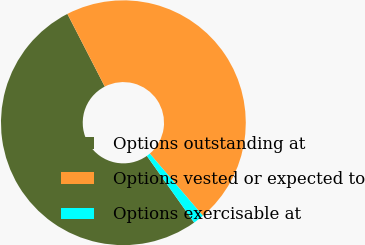<chart> <loc_0><loc_0><loc_500><loc_500><pie_chart><fcel>Options outstanding at<fcel>Options vested or expected to<fcel>Options exercisable at<nl><fcel>52.25%<fcel>46.31%<fcel>1.44%<nl></chart> 